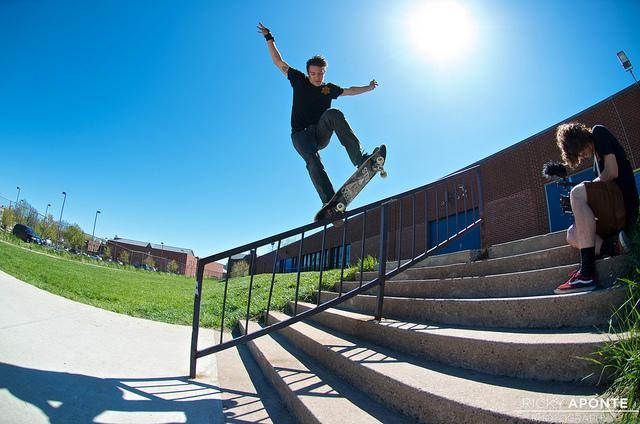Why is there a bright circle?

Choices:
A) sun light
B) edited in
C) bright lamp
D) laser light sun light 